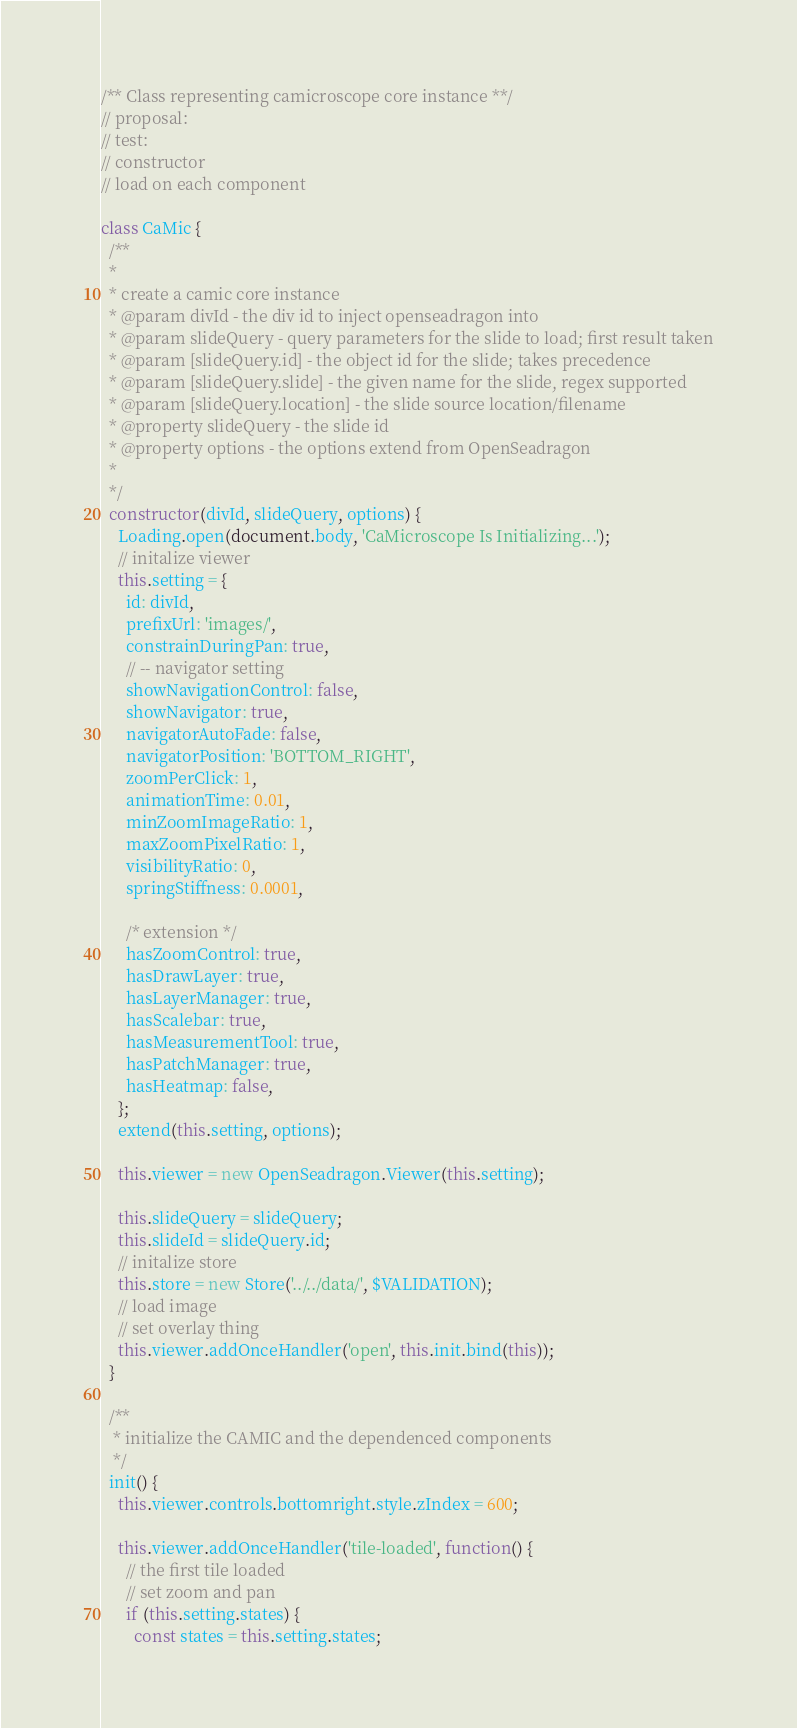<code> <loc_0><loc_0><loc_500><loc_500><_JavaScript_>/** Class representing camicroscope core instance **/
// proposal:
// test:
// constructor
// load on each component

class CaMic {
  /**
  *
  * create a camic core instance
  * @param divId - the div id to inject openseadragon into
  * @param slideQuery - query parameters for the slide to load; first result taken
  * @param [slideQuery.id] - the object id for the slide; takes precedence
  * @param [slideQuery.slide] - the given name for the slide, regex supported
  * @param [slideQuery.location] - the slide source location/filename
  * @property slideQuery - the slide id
  * @property options - the options extend from OpenSeadragon
  *
  */
  constructor(divId, slideQuery, options) {
    Loading.open(document.body, 'CaMicroscope Is Initializing...');
    // initalize viewer
    this.setting = {
      id: divId,
      prefixUrl: 'images/',
      constrainDuringPan: true,
      // -- navigator setting
      showNavigationControl: false,
      showNavigator: true,
      navigatorAutoFade: false,
      navigatorPosition: 'BOTTOM_RIGHT',
      zoomPerClick: 1,
      animationTime: 0.01,
      minZoomImageRatio: 1,
      maxZoomPixelRatio: 1,
      visibilityRatio: 0,
      springStiffness: 0.0001,

      /* extension */
      hasZoomControl: true,
      hasDrawLayer: true,
      hasLayerManager: true,
      hasScalebar: true,
      hasMeasurementTool: true,
      hasPatchManager: true,
      hasHeatmap: false,
    };
    extend(this.setting, options);

    this.viewer = new OpenSeadragon.Viewer(this.setting);

    this.slideQuery = slideQuery;
    this.slideId = slideQuery.id;
    // initalize store
    this.store = new Store('../../data/', $VALIDATION);
    // load image
    // set overlay thing
    this.viewer.addOnceHandler('open', this.init.bind(this));
  }

  /**
   * initialize the CAMIC and the dependenced components
   */
  init() {
    this.viewer.controls.bottomright.style.zIndex = 600;

    this.viewer.addOnceHandler('tile-loaded', function() {
      // the first tile loaded
      // set zoom and pan
      if (this.setting.states) {
        const states = this.setting.states;</code> 